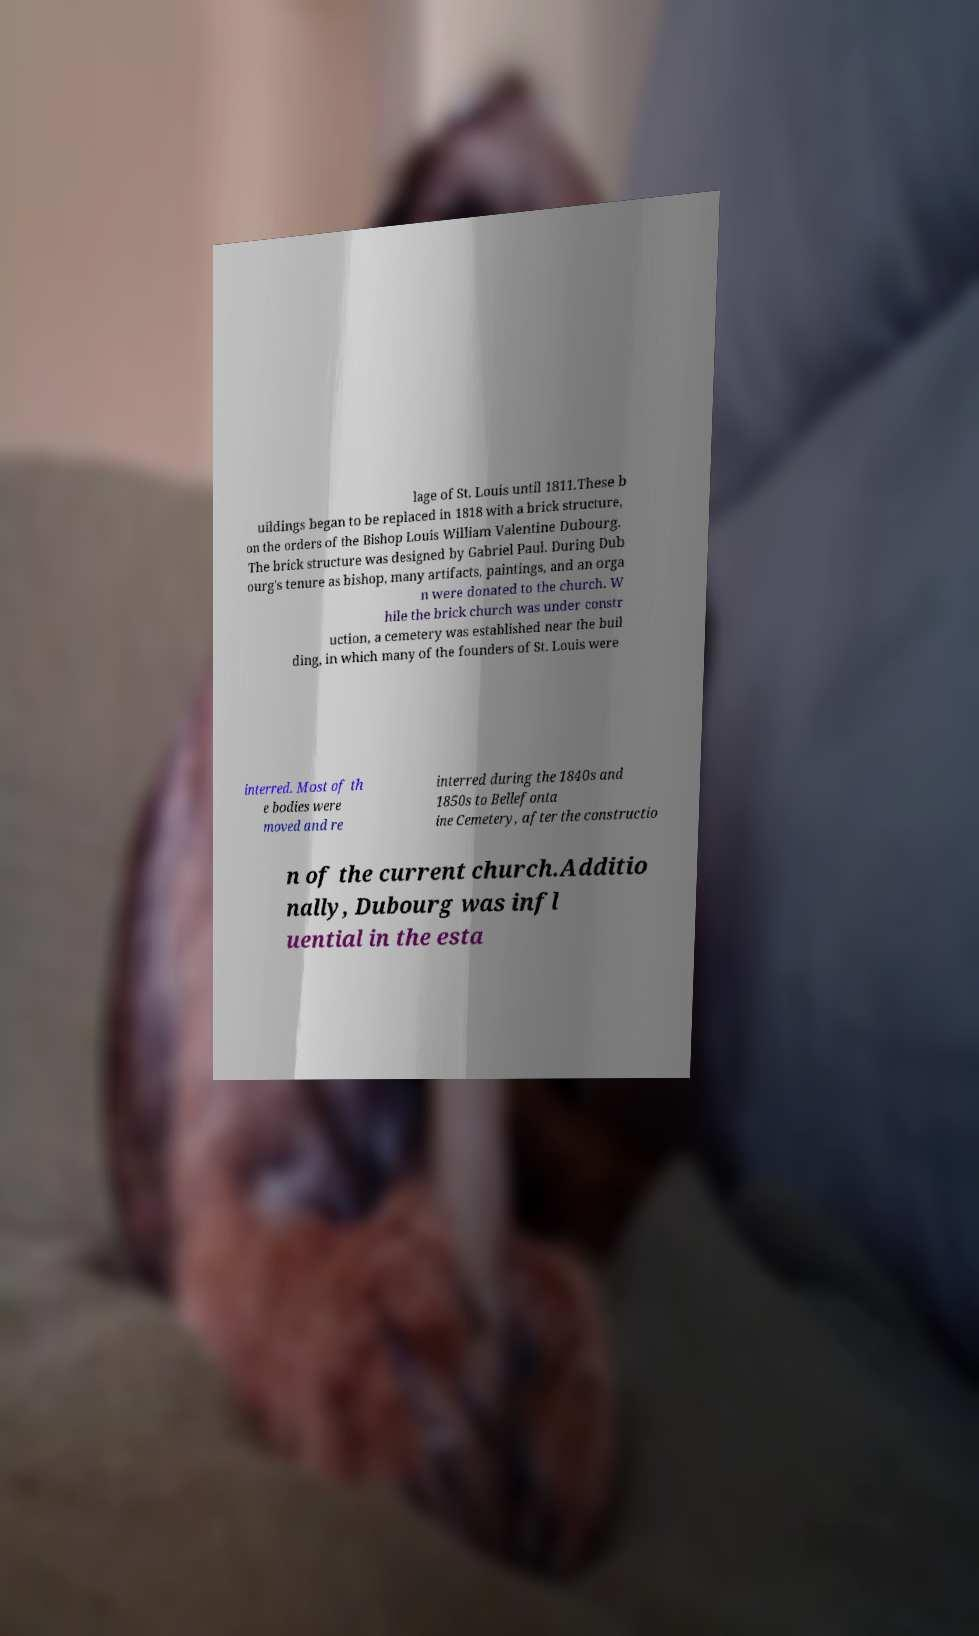There's text embedded in this image that I need extracted. Can you transcribe it verbatim? lage of St. Louis until 1811.These b uildings began to be replaced in 1818 with a brick structure, on the orders of the Bishop Louis William Valentine Dubourg. The brick structure was designed by Gabriel Paul. During Dub ourg's tenure as bishop, many artifacts, paintings, and an orga n were donated to the church. W hile the brick church was under constr uction, a cemetery was established near the buil ding, in which many of the founders of St. Louis were interred. Most of th e bodies were moved and re interred during the 1840s and 1850s to Bellefonta ine Cemetery, after the constructio n of the current church.Additio nally, Dubourg was infl uential in the esta 